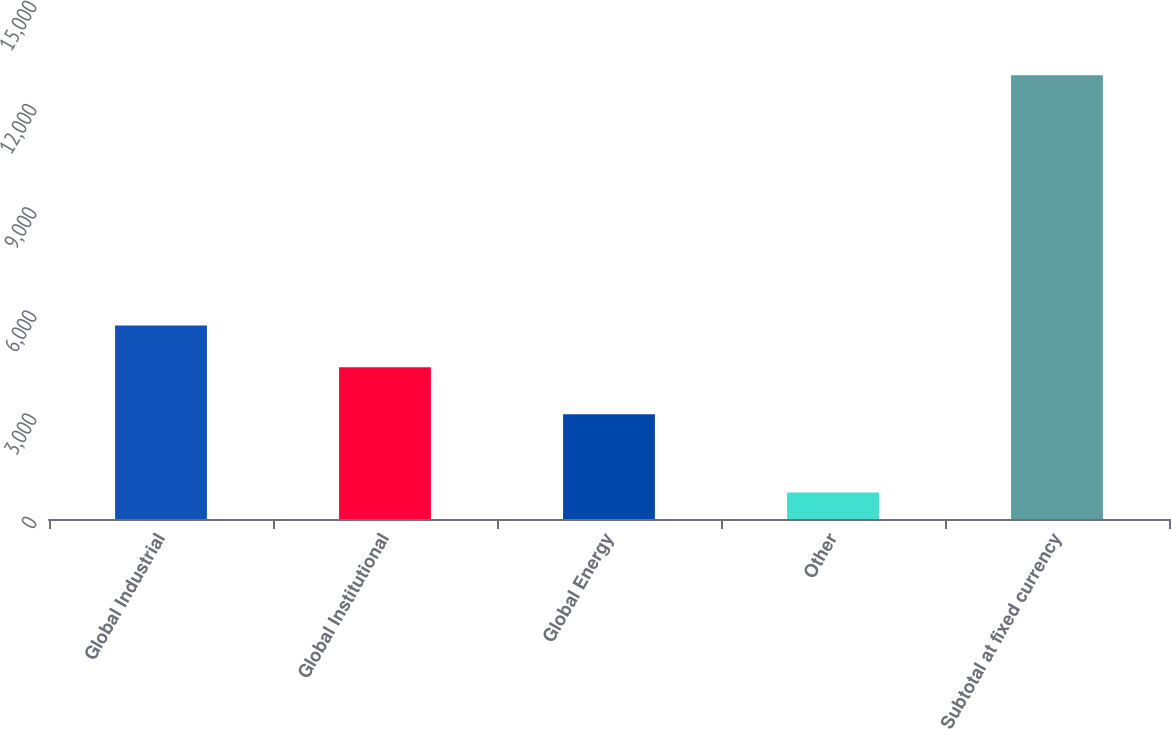Convert chart. <chart><loc_0><loc_0><loc_500><loc_500><bar_chart><fcel>Global Industrial<fcel>Global Institutional<fcel>Global Energy<fcel>Other<fcel>Subtotal at fixed currency<nl><fcel>5624.17<fcel>4411.2<fcel>3042.3<fcel>772.8<fcel>12902.5<nl></chart> 